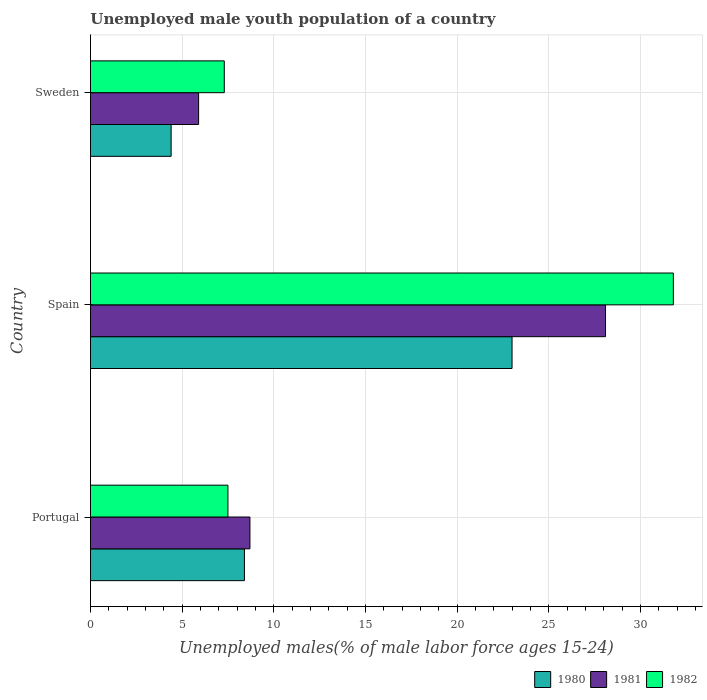How many different coloured bars are there?
Your answer should be compact. 3. How many groups of bars are there?
Offer a very short reply. 3. Are the number of bars per tick equal to the number of legend labels?
Keep it short and to the point. Yes. How many bars are there on the 2nd tick from the top?
Your response must be concise. 3. How many bars are there on the 1st tick from the bottom?
Give a very brief answer. 3. In how many cases, is the number of bars for a given country not equal to the number of legend labels?
Ensure brevity in your answer.  0. What is the percentage of unemployed male youth population in 1981 in Portugal?
Make the answer very short. 8.7. Across all countries, what is the maximum percentage of unemployed male youth population in 1980?
Your answer should be very brief. 23. Across all countries, what is the minimum percentage of unemployed male youth population in 1982?
Offer a very short reply. 7.3. In which country was the percentage of unemployed male youth population in 1981 minimum?
Your answer should be compact. Sweden. What is the total percentage of unemployed male youth population in 1980 in the graph?
Ensure brevity in your answer.  35.8. What is the difference between the percentage of unemployed male youth population in 1982 in Portugal and that in Spain?
Your answer should be compact. -24.3. What is the difference between the percentage of unemployed male youth population in 1982 in Sweden and the percentage of unemployed male youth population in 1981 in Portugal?
Your answer should be compact. -1.4. What is the average percentage of unemployed male youth population in 1981 per country?
Offer a very short reply. 14.23. What is the difference between the percentage of unemployed male youth population in 1980 and percentage of unemployed male youth population in 1981 in Sweden?
Offer a terse response. -1.5. What is the ratio of the percentage of unemployed male youth population in 1980 in Spain to that in Sweden?
Offer a very short reply. 5.23. What is the difference between the highest and the second highest percentage of unemployed male youth population in 1982?
Offer a very short reply. 24.3. What is the difference between the highest and the lowest percentage of unemployed male youth population in 1982?
Your response must be concise. 24.5. Is the sum of the percentage of unemployed male youth population in 1980 in Portugal and Sweden greater than the maximum percentage of unemployed male youth population in 1982 across all countries?
Ensure brevity in your answer.  No. What does the 2nd bar from the top in Portugal represents?
Offer a very short reply. 1981. Is it the case that in every country, the sum of the percentage of unemployed male youth population in 1980 and percentage of unemployed male youth population in 1981 is greater than the percentage of unemployed male youth population in 1982?
Provide a succinct answer. Yes. Are all the bars in the graph horizontal?
Your response must be concise. Yes. How many countries are there in the graph?
Offer a terse response. 3. What is the difference between two consecutive major ticks on the X-axis?
Provide a short and direct response. 5. Are the values on the major ticks of X-axis written in scientific E-notation?
Make the answer very short. No. Does the graph contain any zero values?
Your answer should be very brief. No. Does the graph contain grids?
Your answer should be very brief. Yes. How many legend labels are there?
Offer a terse response. 3. What is the title of the graph?
Offer a terse response. Unemployed male youth population of a country. What is the label or title of the X-axis?
Your answer should be compact. Unemployed males(% of male labor force ages 15-24). What is the Unemployed males(% of male labor force ages 15-24) of 1980 in Portugal?
Your answer should be very brief. 8.4. What is the Unemployed males(% of male labor force ages 15-24) in 1981 in Portugal?
Ensure brevity in your answer.  8.7. What is the Unemployed males(% of male labor force ages 15-24) of 1980 in Spain?
Provide a succinct answer. 23. What is the Unemployed males(% of male labor force ages 15-24) of 1981 in Spain?
Offer a terse response. 28.1. What is the Unemployed males(% of male labor force ages 15-24) of 1982 in Spain?
Ensure brevity in your answer.  31.8. What is the Unemployed males(% of male labor force ages 15-24) of 1980 in Sweden?
Give a very brief answer. 4.4. What is the Unemployed males(% of male labor force ages 15-24) of 1981 in Sweden?
Give a very brief answer. 5.9. What is the Unemployed males(% of male labor force ages 15-24) in 1982 in Sweden?
Keep it short and to the point. 7.3. Across all countries, what is the maximum Unemployed males(% of male labor force ages 15-24) of 1980?
Provide a succinct answer. 23. Across all countries, what is the maximum Unemployed males(% of male labor force ages 15-24) in 1981?
Make the answer very short. 28.1. Across all countries, what is the maximum Unemployed males(% of male labor force ages 15-24) of 1982?
Your response must be concise. 31.8. Across all countries, what is the minimum Unemployed males(% of male labor force ages 15-24) of 1980?
Provide a succinct answer. 4.4. Across all countries, what is the minimum Unemployed males(% of male labor force ages 15-24) of 1981?
Make the answer very short. 5.9. Across all countries, what is the minimum Unemployed males(% of male labor force ages 15-24) of 1982?
Ensure brevity in your answer.  7.3. What is the total Unemployed males(% of male labor force ages 15-24) of 1980 in the graph?
Ensure brevity in your answer.  35.8. What is the total Unemployed males(% of male labor force ages 15-24) of 1981 in the graph?
Provide a short and direct response. 42.7. What is the total Unemployed males(% of male labor force ages 15-24) in 1982 in the graph?
Offer a very short reply. 46.6. What is the difference between the Unemployed males(% of male labor force ages 15-24) in 1980 in Portugal and that in Spain?
Your answer should be very brief. -14.6. What is the difference between the Unemployed males(% of male labor force ages 15-24) in 1981 in Portugal and that in Spain?
Provide a succinct answer. -19.4. What is the difference between the Unemployed males(% of male labor force ages 15-24) of 1982 in Portugal and that in Spain?
Ensure brevity in your answer.  -24.3. What is the difference between the Unemployed males(% of male labor force ages 15-24) in 1981 in Portugal and that in Sweden?
Your answer should be very brief. 2.8. What is the difference between the Unemployed males(% of male labor force ages 15-24) in 1982 in Portugal and that in Sweden?
Make the answer very short. 0.2. What is the difference between the Unemployed males(% of male labor force ages 15-24) of 1981 in Spain and that in Sweden?
Offer a terse response. 22.2. What is the difference between the Unemployed males(% of male labor force ages 15-24) of 1982 in Spain and that in Sweden?
Make the answer very short. 24.5. What is the difference between the Unemployed males(% of male labor force ages 15-24) of 1980 in Portugal and the Unemployed males(% of male labor force ages 15-24) of 1981 in Spain?
Make the answer very short. -19.7. What is the difference between the Unemployed males(% of male labor force ages 15-24) in 1980 in Portugal and the Unemployed males(% of male labor force ages 15-24) in 1982 in Spain?
Ensure brevity in your answer.  -23.4. What is the difference between the Unemployed males(% of male labor force ages 15-24) of 1981 in Portugal and the Unemployed males(% of male labor force ages 15-24) of 1982 in Spain?
Ensure brevity in your answer.  -23.1. What is the difference between the Unemployed males(% of male labor force ages 15-24) of 1980 in Portugal and the Unemployed males(% of male labor force ages 15-24) of 1982 in Sweden?
Keep it short and to the point. 1.1. What is the difference between the Unemployed males(% of male labor force ages 15-24) of 1981 in Spain and the Unemployed males(% of male labor force ages 15-24) of 1982 in Sweden?
Your answer should be very brief. 20.8. What is the average Unemployed males(% of male labor force ages 15-24) of 1980 per country?
Provide a short and direct response. 11.93. What is the average Unemployed males(% of male labor force ages 15-24) of 1981 per country?
Make the answer very short. 14.23. What is the average Unemployed males(% of male labor force ages 15-24) in 1982 per country?
Provide a short and direct response. 15.53. What is the difference between the Unemployed males(% of male labor force ages 15-24) of 1981 and Unemployed males(% of male labor force ages 15-24) of 1982 in Portugal?
Offer a terse response. 1.2. What is the difference between the Unemployed males(% of male labor force ages 15-24) of 1980 and Unemployed males(% of male labor force ages 15-24) of 1981 in Spain?
Offer a very short reply. -5.1. What is the difference between the Unemployed males(% of male labor force ages 15-24) in 1980 and Unemployed males(% of male labor force ages 15-24) in 1982 in Spain?
Ensure brevity in your answer.  -8.8. What is the difference between the Unemployed males(% of male labor force ages 15-24) of 1981 and Unemployed males(% of male labor force ages 15-24) of 1982 in Spain?
Your answer should be very brief. -3.7. What is the difference between the Unemployed males(% of male labor force ages 15-24) of 1980 and Unemployed males(% of male labor force ages 15-24) of 1981 in Sweden?
Your answer should be compact. -1.5. What is the difference between the Unemployed males(% of male labor force ages 15-24) of 1980 and Unemployed males(% of male labor force ages 15-24) of 1982 in Sweden?
Offer a terse response. -2.9. What is the difference between the Unemployed males(% of male labor force ages 15-24) in 1981 and Unemployed males(% of male labor force ages 15-24) in 1982 in Sweden?
Offer a terse response. -1.4. What is the ratio of the Unemployed males(% of male labor force ages 15-24) in 1980 in Portugal to that in Spain?
Your answer should be very brief. 0.37. What is the ratio of the Unemployed males(% of male labor force ages 15-24) of 1981 in Portugal to that in Spain?
Provide a succinct answer. 0.31. What is the ratio of the Unemployed males(% of male labor force ages 15-24) of 1982 in Portugal to that in Spain?
Offer a terse response. 0.24. What is the ratio of the Unemployed males(% of male labor force ages 15-24) of 1980 in Portugal to that in Sweden?
Ensure brevity in your answer.  1.91. What is the ratio of the Unemployed males(% of male labor force ages 15-24) in 1981 in Portugal to that in Sweden?
Give a very brief answer. 1.47. What is the ratio of the Unemployed males(% of male labor force ages 15-24) of 1982 in Portugal to that in Sweden?
Make the answer very short. 1.03. What is the ratio of the Unemployed males(% of male labor force ages 15-24) in 1980 in Spain to that in Sweden?
Your answer should be compact. 5.23. What is the ratio of the Unemployed males(% of male labor force ages 15-24) in 1981 in Spain to that in Sweden?
Offer a terse response. 4.76. What is the ratio of the Unemployed males(% of male labor force ages 15-24) in 1982 in Spain to that in Sweden?
Your answer should be very brief. 4.36. What is the difference between the highest and the second highest Unemployed males(% of male labor force ages 15-24) of 1981?
Give a very brief answer. 19.4. What is the difference between the highest and the second highest Unemployed males(% of male labor force ages 15-24) in 1982?
Your response must be concise. 24.3. What is the difference between the highest and the lowest Unemployed males(% of male labor force ages 15-24) of 1981?
Your response must be concise. 22.2. 